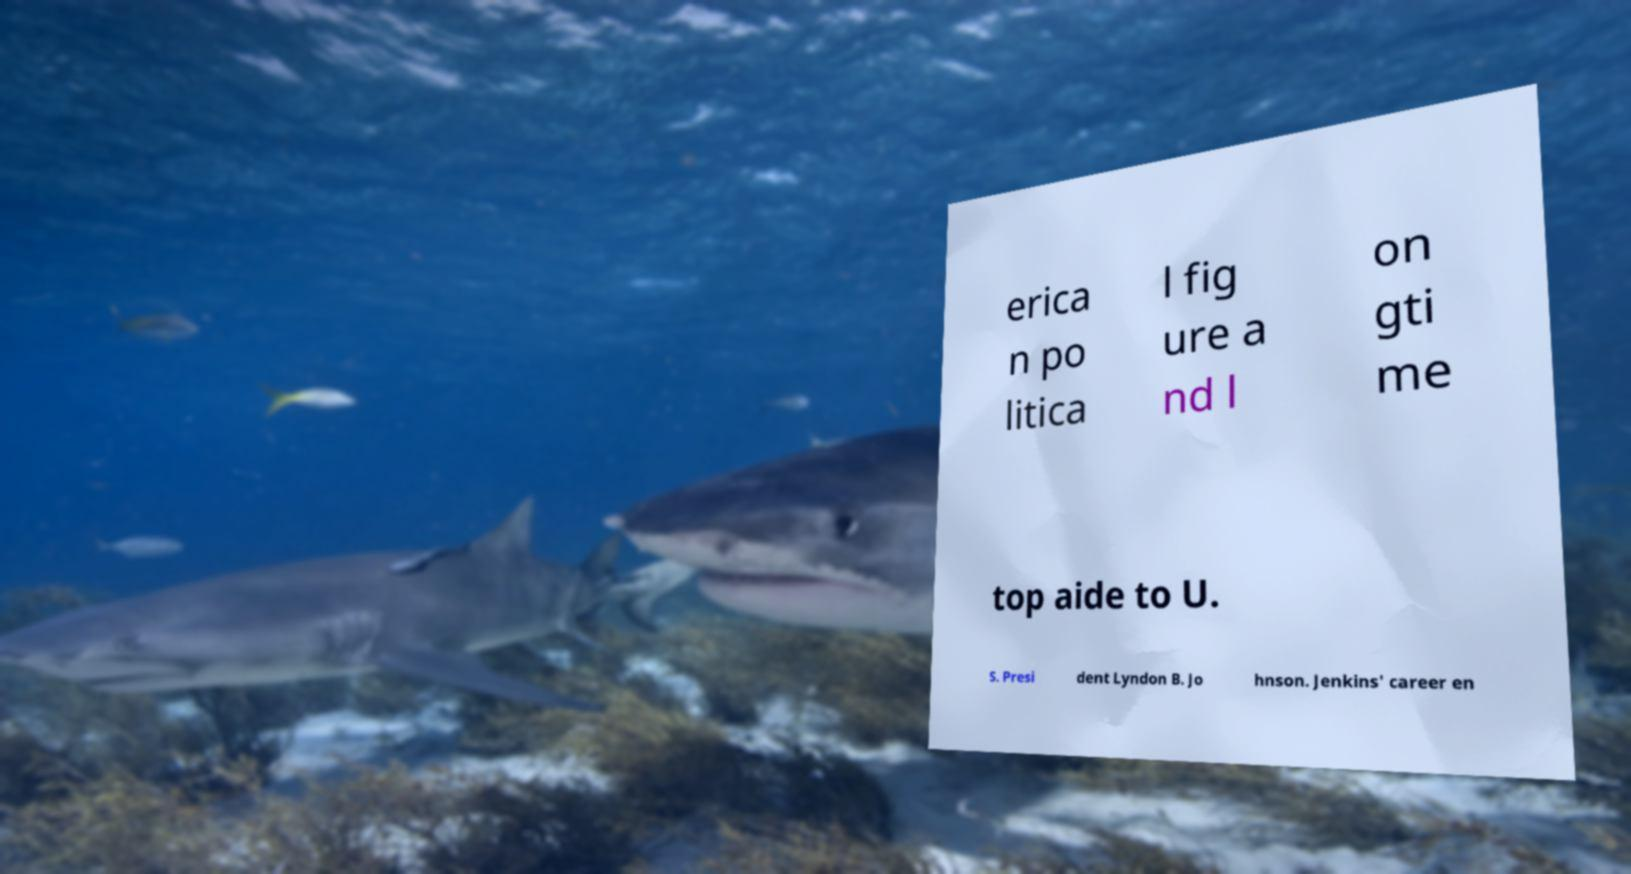Can you accurately transcribe the text from the provided image for me? erica n po litica l fig ure a nd l on gti me top aide to U. S. Presi dent Lyndon B. Jo hnson. Jenkins' career en 